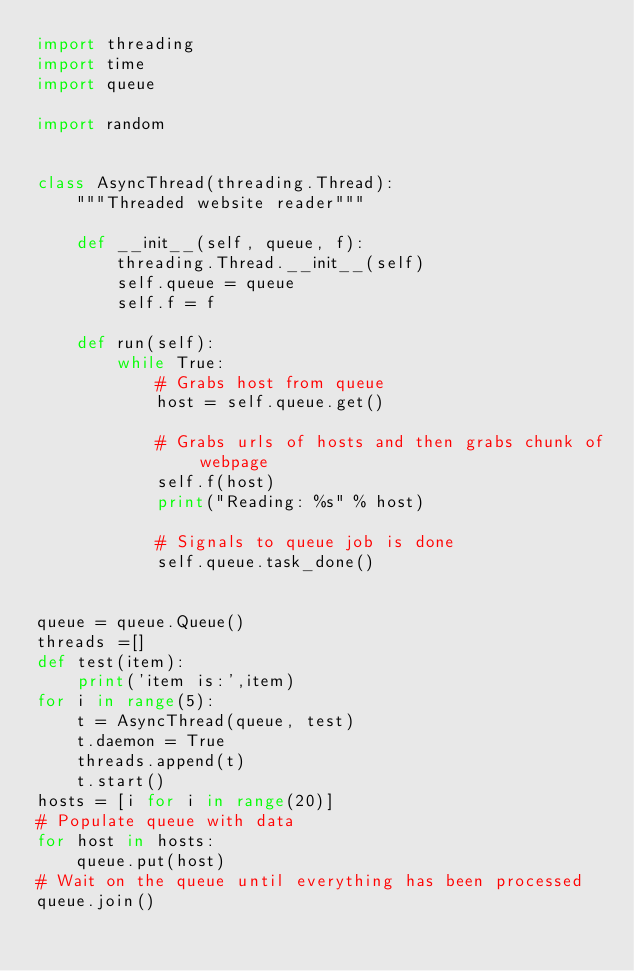<code> <loc_0><loc_0><loc_500><loc_500><_Python_>import threading
import time
import queue

import random


class AsyncThread(threading.Thread):
    """Threaded website reader"""

    def __init__(self, queue, f):
        threading.Thread.__init__(self)
        self.queue = queue
        self.f = f

    def run(self):
        while True:
            # Grabs host from queue
            host = self.queue.get()

            # Grabs urls of hosts and then grabs chunk of webpage
            self.f(host)
            print("Reading: %s" % host)

            # Signals to queue job is done
            self.queue.task_done()


queue = queue.Queue()
threads =[]
def test(item):
    print('item is:',item)
for i in range(5):
    t = AsyncThread(queue, test)
    t.daemon = True
    threads.append(t)
    t.start()
hosts = [i for i in range(20)]
# Populate queue with data
for host in hosts:
    queue.put(host)
# Wait on the queue until everything has been processed
queue.join()
</code> 